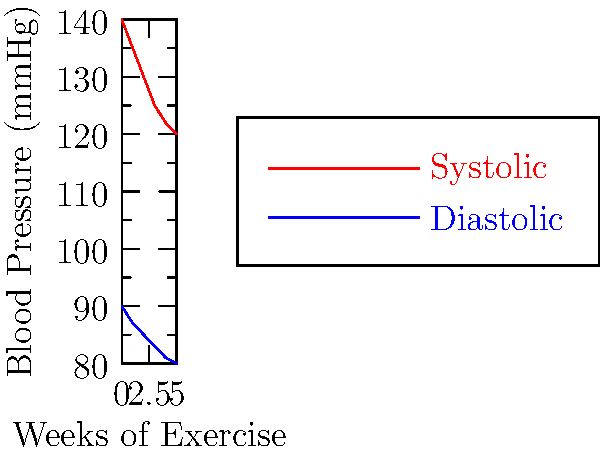Based on the graph showing the effects of exercise on blood pressure over time, what is the approximate reduction in systolic blood pressure after 5 weeks of regular exercise? To find the reduction in systolic blood pressure after 5 weeks of exercise:

1. Identify the systolic blood pressure (top red line) at week 0: 140 mmHg
2. Identify the systolic blood pressure at week 5: 120 mmHg
3. Calculate the difference:
   $140 \text{ mmHg} - 120 \text{ mmHg} = 20 \text{ mmHg}$

The graph shows that regular exercise over 5 weeks led to a reduction of approximately 20 mmHg in systolic blood pressure.
Answer: 20 mmHg 